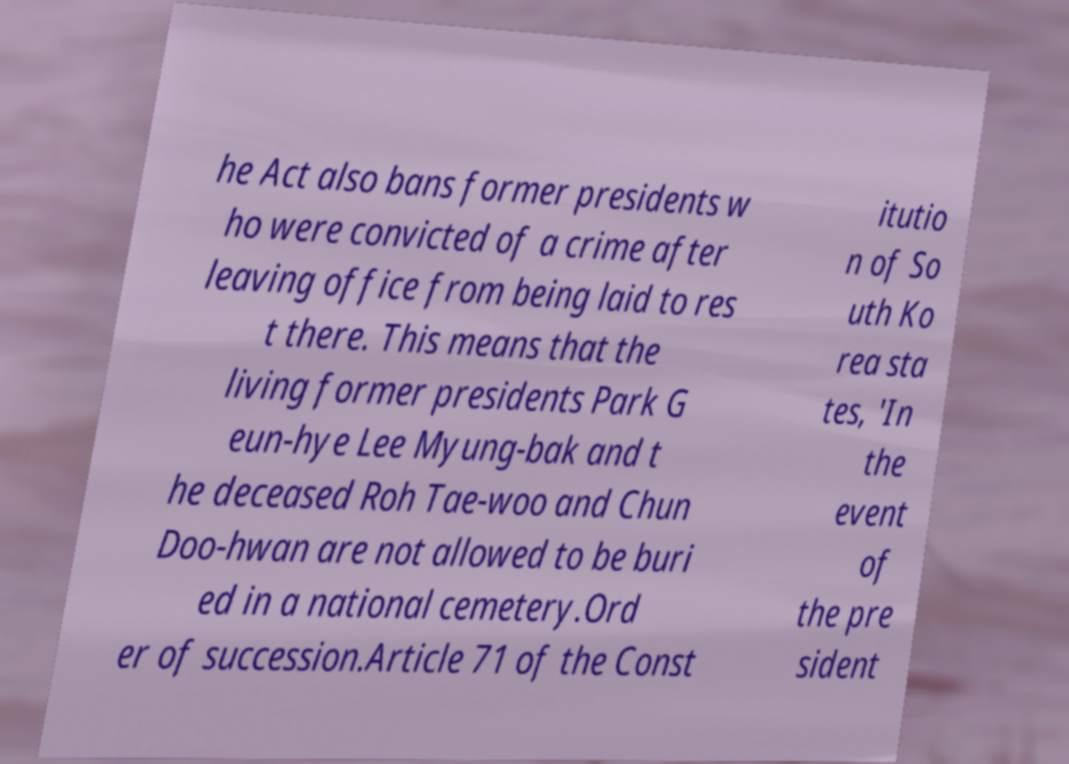There's text embedded in this image that I need extracted. Can you transcribe it verbatim? he Act also bans former presidents w ho were convicted of a crime after leaving office from being laid to res t there. This means that the living former presidents Park G eun-hye Lee Myung-bak and t he deceased Roh Tae-woo and Chun Doo-hwan are not allowed to be buri ed in a national cemetery.Ord er of succession.Article 71 of the Const itutio n of So uth Ko rea sta tes, 'In the event of the pre sident 